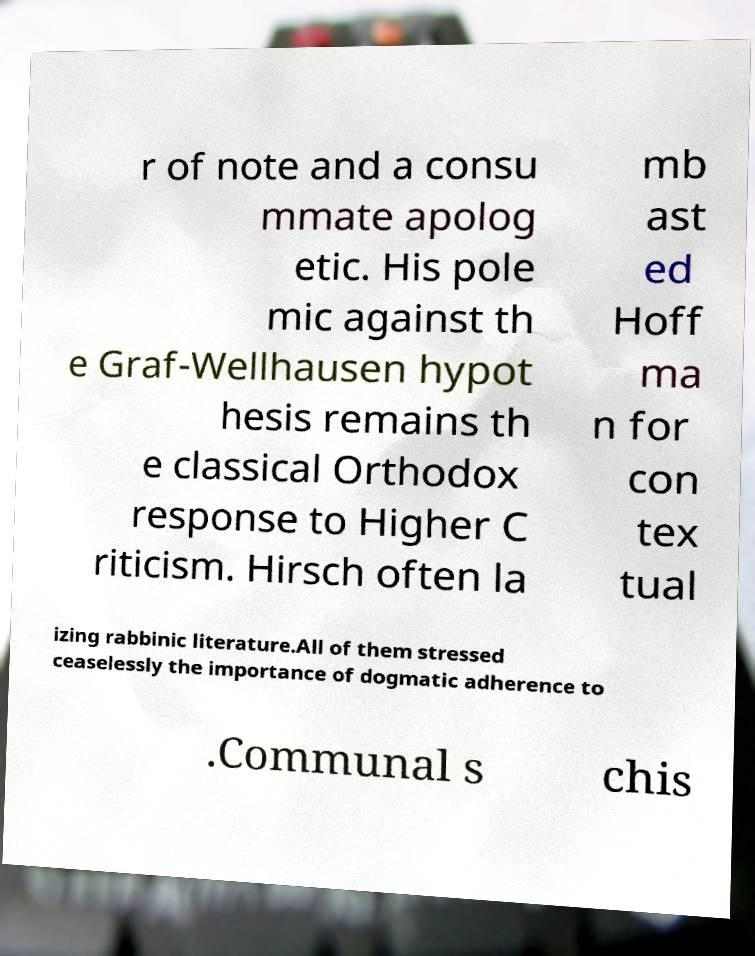There's text embedded in this image that I need extracted. Can you transcribe it verbatim? r of note and a consu mmate apolog etic. His pole mic against th e Graf-Wellhausen hypot hesis remains th e classical Orthodox response to Higher C riticism. Hirsch often la mb ast ed Hoff ma n for con tex tual izing rabbinic literature.All of them stressed ceaselessly the importance of dogmatic adherence to .Communal s chis 